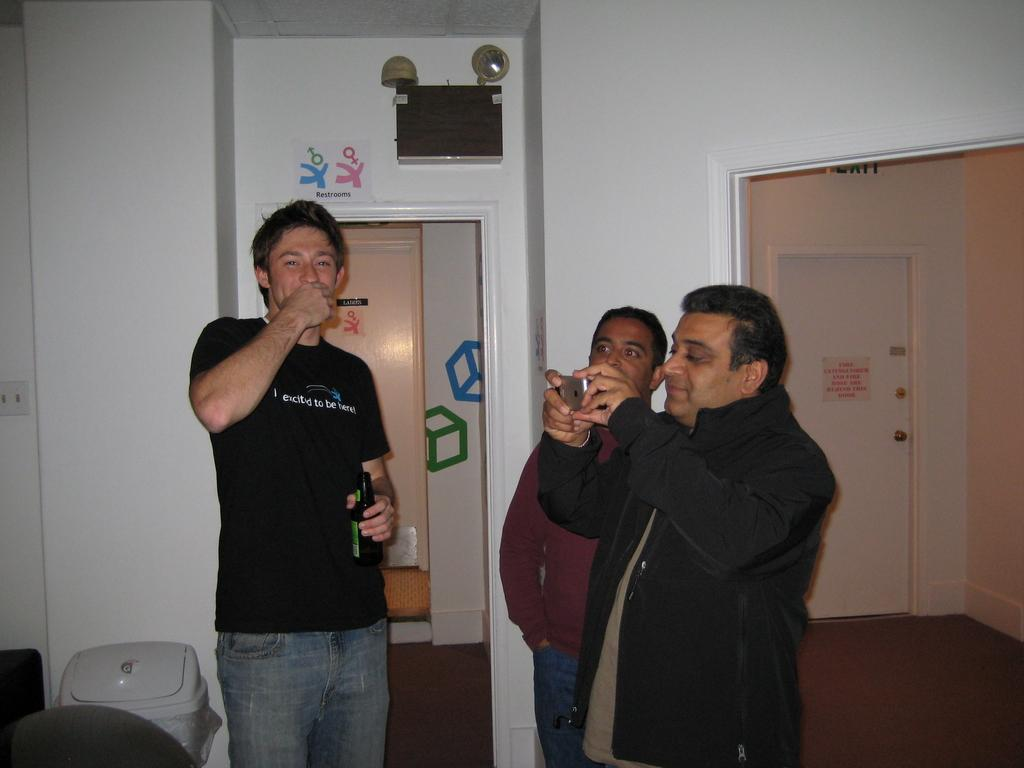How many people are in the group visible in the image? There is a group of people in the image, but the exact number is not specified. What is one person in the group doing? One person in the group is holding a camera. What can be seen on the wall in the background? There are objects on the wall in the background. What is located beside the group of people? There is a dustbin beside the group of people. What type of vest is the ship wearing in the image? There is no ship or vest present in the image. Can you provide an example of a similar group of people in a different setting? The provided facts do not allow for a comparison to a different setting, as we only have information about the group of people and their immediate surroundings in this image. 